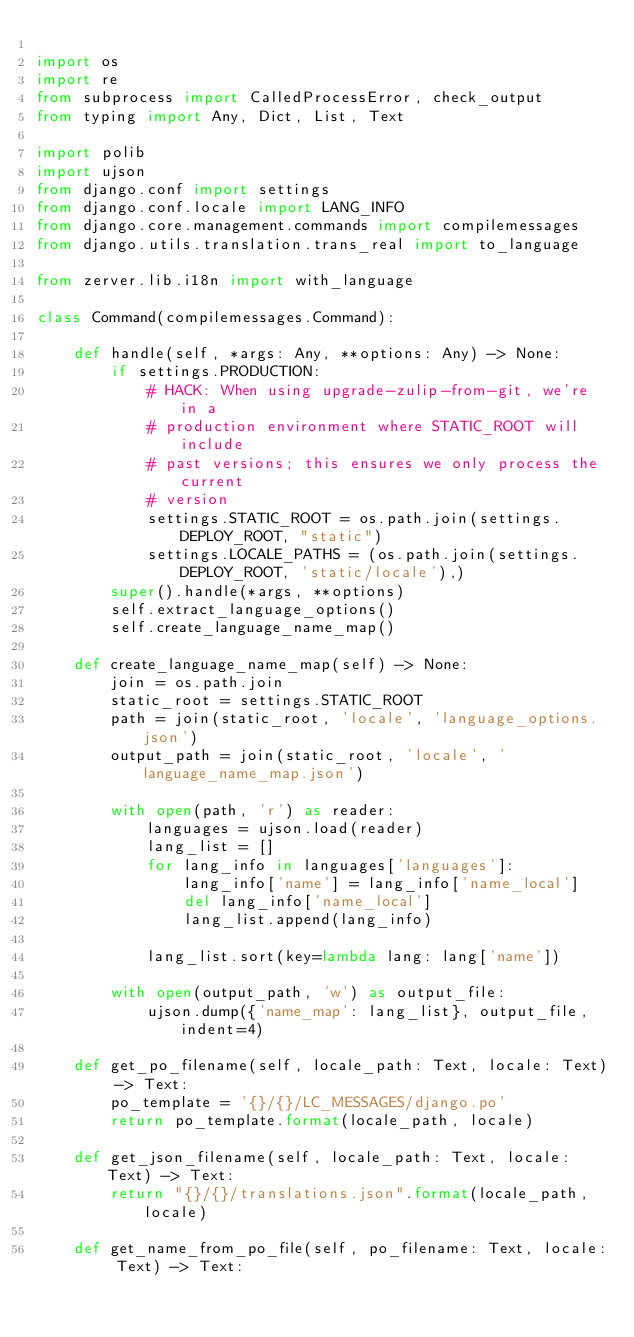Convert code to text. <code><loc_0><loc_0><loc_500><loc_500><_Python_>
import os
import re
from subprocess import CalledProcessError, check_output
from typing import Any, Dict, List, Text

import polib
import ujson
from django.conf import settings
from django.conf.locale import LANG_INFO
from django.core.management.commands import compilemessages
from django.utils.translation.trans_real import to_language

from zerver.lib.i18n import with_language

class Command(compilemessages.Command):

    def handle(self, *args: Any, **options: Any) -> None:
        if settings.PRODUCTION:
            # HACK: When using upgrade-zulip-from-git, we're in a
            # production environment where STATIC_ROOT will include
            # past versions; this ensures we only process the current
            # version
            settings.STATIC_ROOT = os.path.join(settings.DEPLOY_ROOT, "static")
            settings.LOCALE_PATHS = (os.path.join(settings.DEPLOY_ROOT, 'static/locale'),)
        super().handle(*args, **options)
        self.extract_language_options()
        self.create_language_name_map()

    def create_language_name_map(self) -> None:
        join = os.path.join
        static_root = settings.STATIC_ROOT
        path = join(static_root, 'locale', 'language_options.json')
        output_path = join(static_root, 'locale', 'language_name_map.json')

        with open(path, 'r') as reader:
            languages = ujson.load(reader)
            lang_list = []
            for lang_info in languages['languages']:
                lang_info['name'] = lang_info['name_local']
                del lang_info['name_local']
                lang_list.append(lang_info)

            lang_list.sort(key=lambda lang: lang['name'])

        with open(output_path, 'w') as output_file:
            ujson.dump({'name_map': lang_list}, output_file, indent=4)

    def get_po_filename(self, locale_path: Text, locale: Text) -> Text:
        po_template = '{}/{}/LC_MESSAGES/django.po'
        return po_template.format(locale_path, locale)

    def get_json_filename(self, locale_path: Text, locale: Text) -> Text:
        return "{}/{}/translations.json".format(locale_path, locale)

    def get_name_from_po_file(self, po_filename: Text, locale: Text) -> Text:</code> 